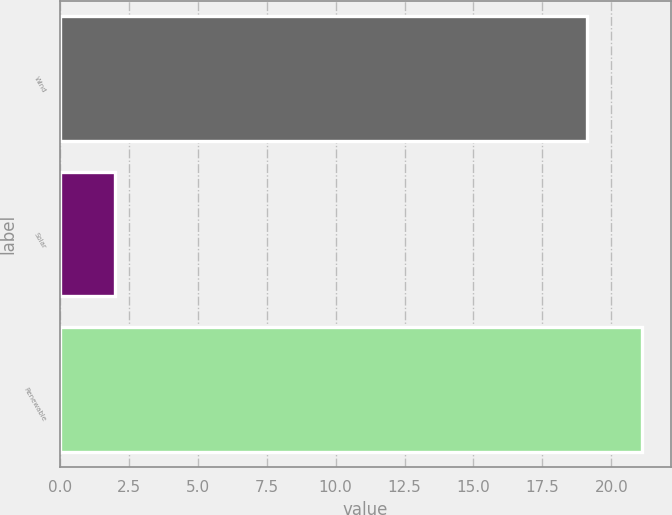<chart> <loc_0><loc_0><loc_500><loc_500><bar_chart><fcel>Wind<fcel>Solar<fcel>Renewable<nl><fcel>19.1<fcel>2<fcel>21.1<nl></chart> 